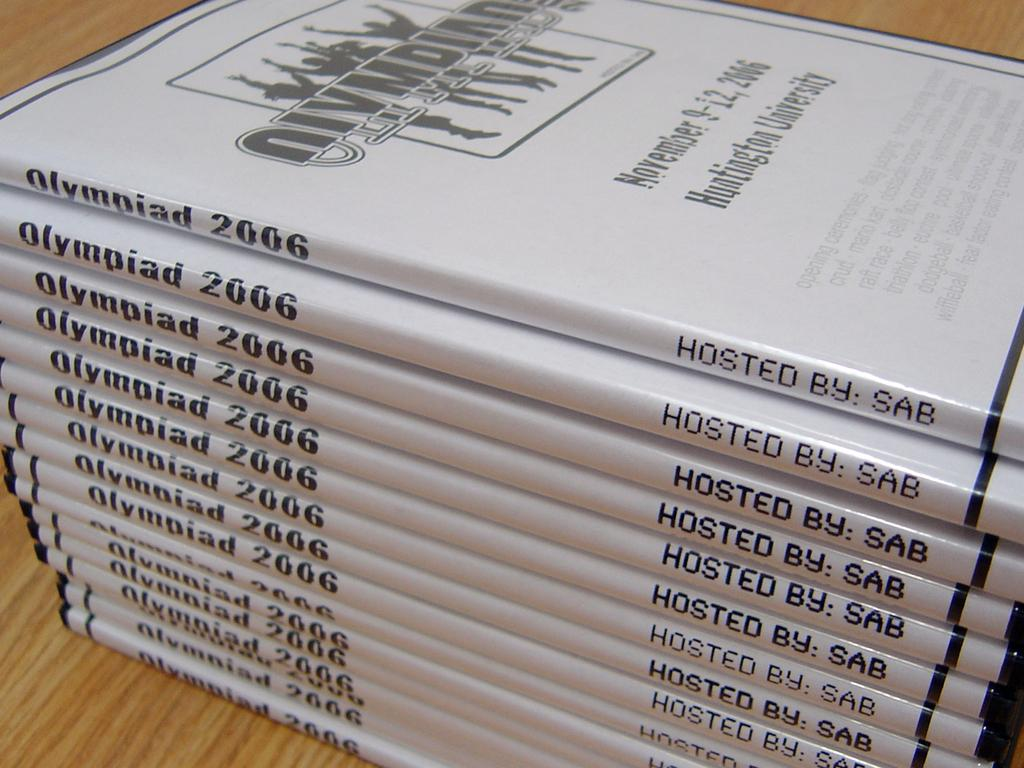Provide a one-sentence caption for the provided image. Books of the Olympiad that is hosted by sab. 